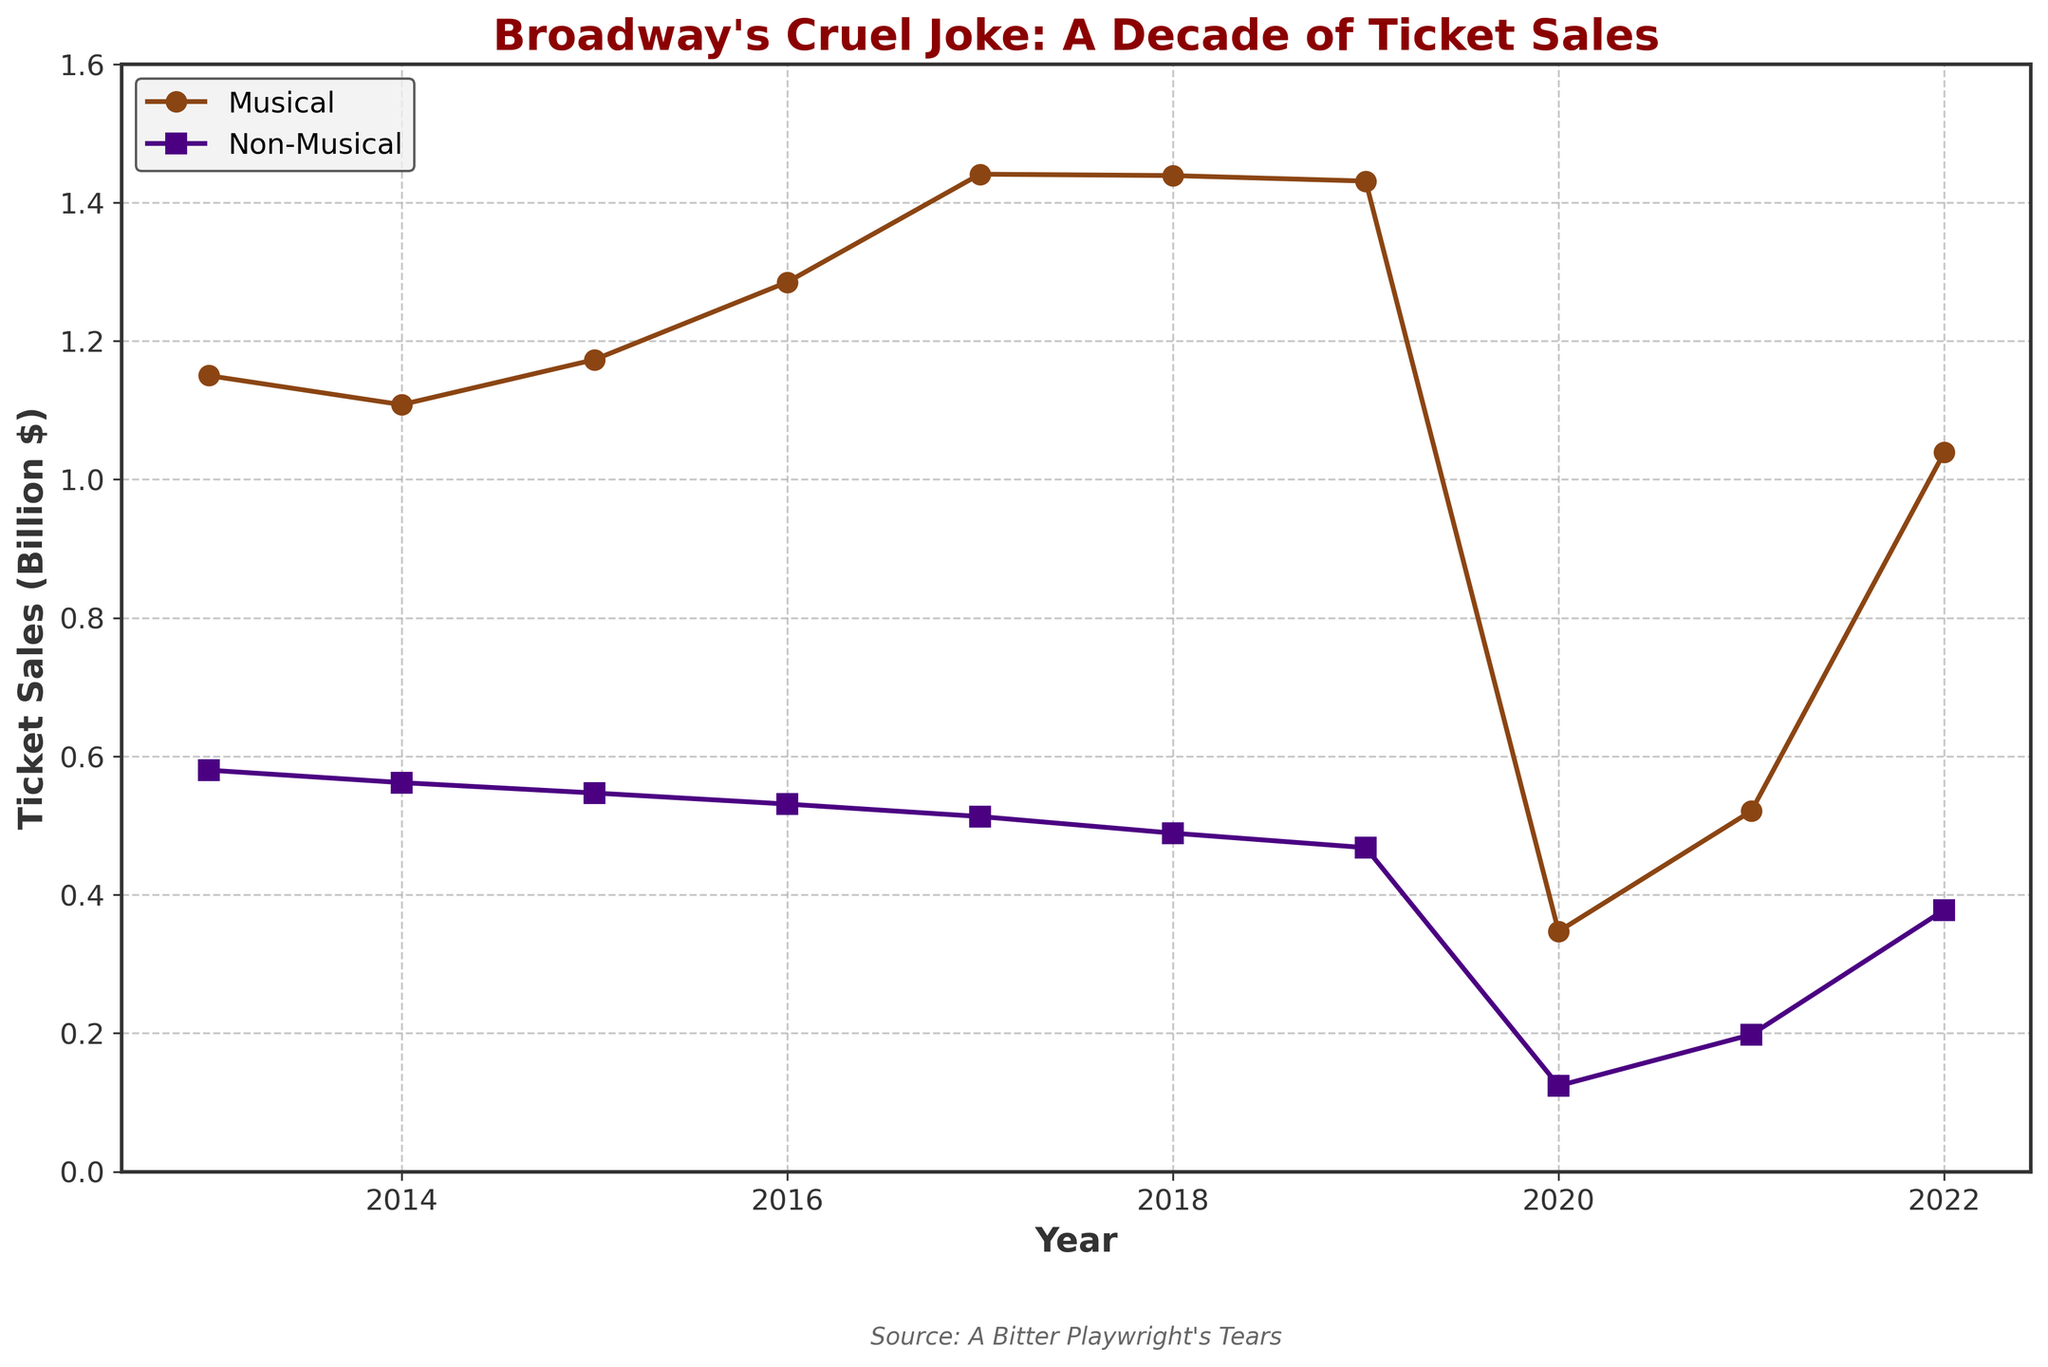what is the lowest value for musical ticket sales over the decade? By examining the line representing musical ticket sales, the lowest drop occurs in 2020 where the value is significantly lower than in other years.
Answer: 347,000,000 Did musical or non-musical productions experience a sharper drop in ticket sales between 2019 and 2020? Both types of productions experienced a drop, but non-musical ticket sales dropped from around 468,000,000 to 124,000,000, while musical dropped from roughly 1.43 billion to 347 million. Calculating the percentage decrease for both: 
Musical: (347,000,000 - 1,430,000,000) / 1,430,000,000 * 100 ≈ -75.76%, Non-Musical: (124,000,000 - 468,000,000) / 468,000,000 * 100 ≈ -73.50%. So, musicals had a slightly sharper drop.
Answer: Musical What was the change in ticket sales for non-musical productions from 2013 to 2016? The non-musical ticket sales were 580,000,000 in 2013 and decreased to 531,000,000 in 2016. The change is 580,000,000 - 531,000,000 = 49,000,000.
Answer: 49,000,000 Between which consecutive years did musical ticket sales see the highest increase? Observing the musical ticket sales line, the largest increase occurs between 2015 and 2016, going from approximately 1.17 billion to 1.29 billion.
Answer: 2015-2016 In what year did musical ticket sales peak? The peak value for musical ticket sales occurred when the y-axis value is highest. This happens in 2017 with sales of roughly 1.44 billion.
Answer: 2017 How do musical ticket sales in 2021 compare to those in 2018? By looking at the lines for musical ticket sales in both years, we see that sales in 2021 are around 521,000,000, while in 2018, they are approximately 1.44 billion. This shows a significant reduction in 2021 compared to 2018.
Answer: Lower What is the average value of non-musical ticket sales from 2013 to 2022, inclusive? Summing the values: 580,000,000 + 562,000,000 + 547,000,000 + 531,000,000 + 513,000,000 + 489,000,000 + 468,000,000 + 124,000,000 + 198,000,000 + 378,000,000 = 4,390,000,000. Then, dividing by the number of years (10): 
4,390,000,000 / 10 = 439,000,000.
Answer: 439,000,000 What’s the total ticket sales for non-musical productions for the years 2019 and 2020 combined? The values for non-musical productions in 2019 and 2020 are 468,000,000 and 124,000,000 respectively. So, the total is:
468,000,000 + 124,000,000 = 592,000,000.
Answer: 592,000,000 Do musical ticket sales in 2022 exceed non-musical ticket sales in any year depicted in the graph? Musical sales in 2022 are measured at around 1.03 billion. Non-musical sales in all years range from 124,000,000 to 580,000,000, none of which exceed musical sales in 2022.
Answer: Yes What is the trend for non-musical ticket sales over the decade? Observing the line for non-musical ticket sales over the decade shows a decreasing trend overall, with a dramatic dip in 2020 due to the pandemic and a partial recovery afterward.
Answer: Decreasing trend 